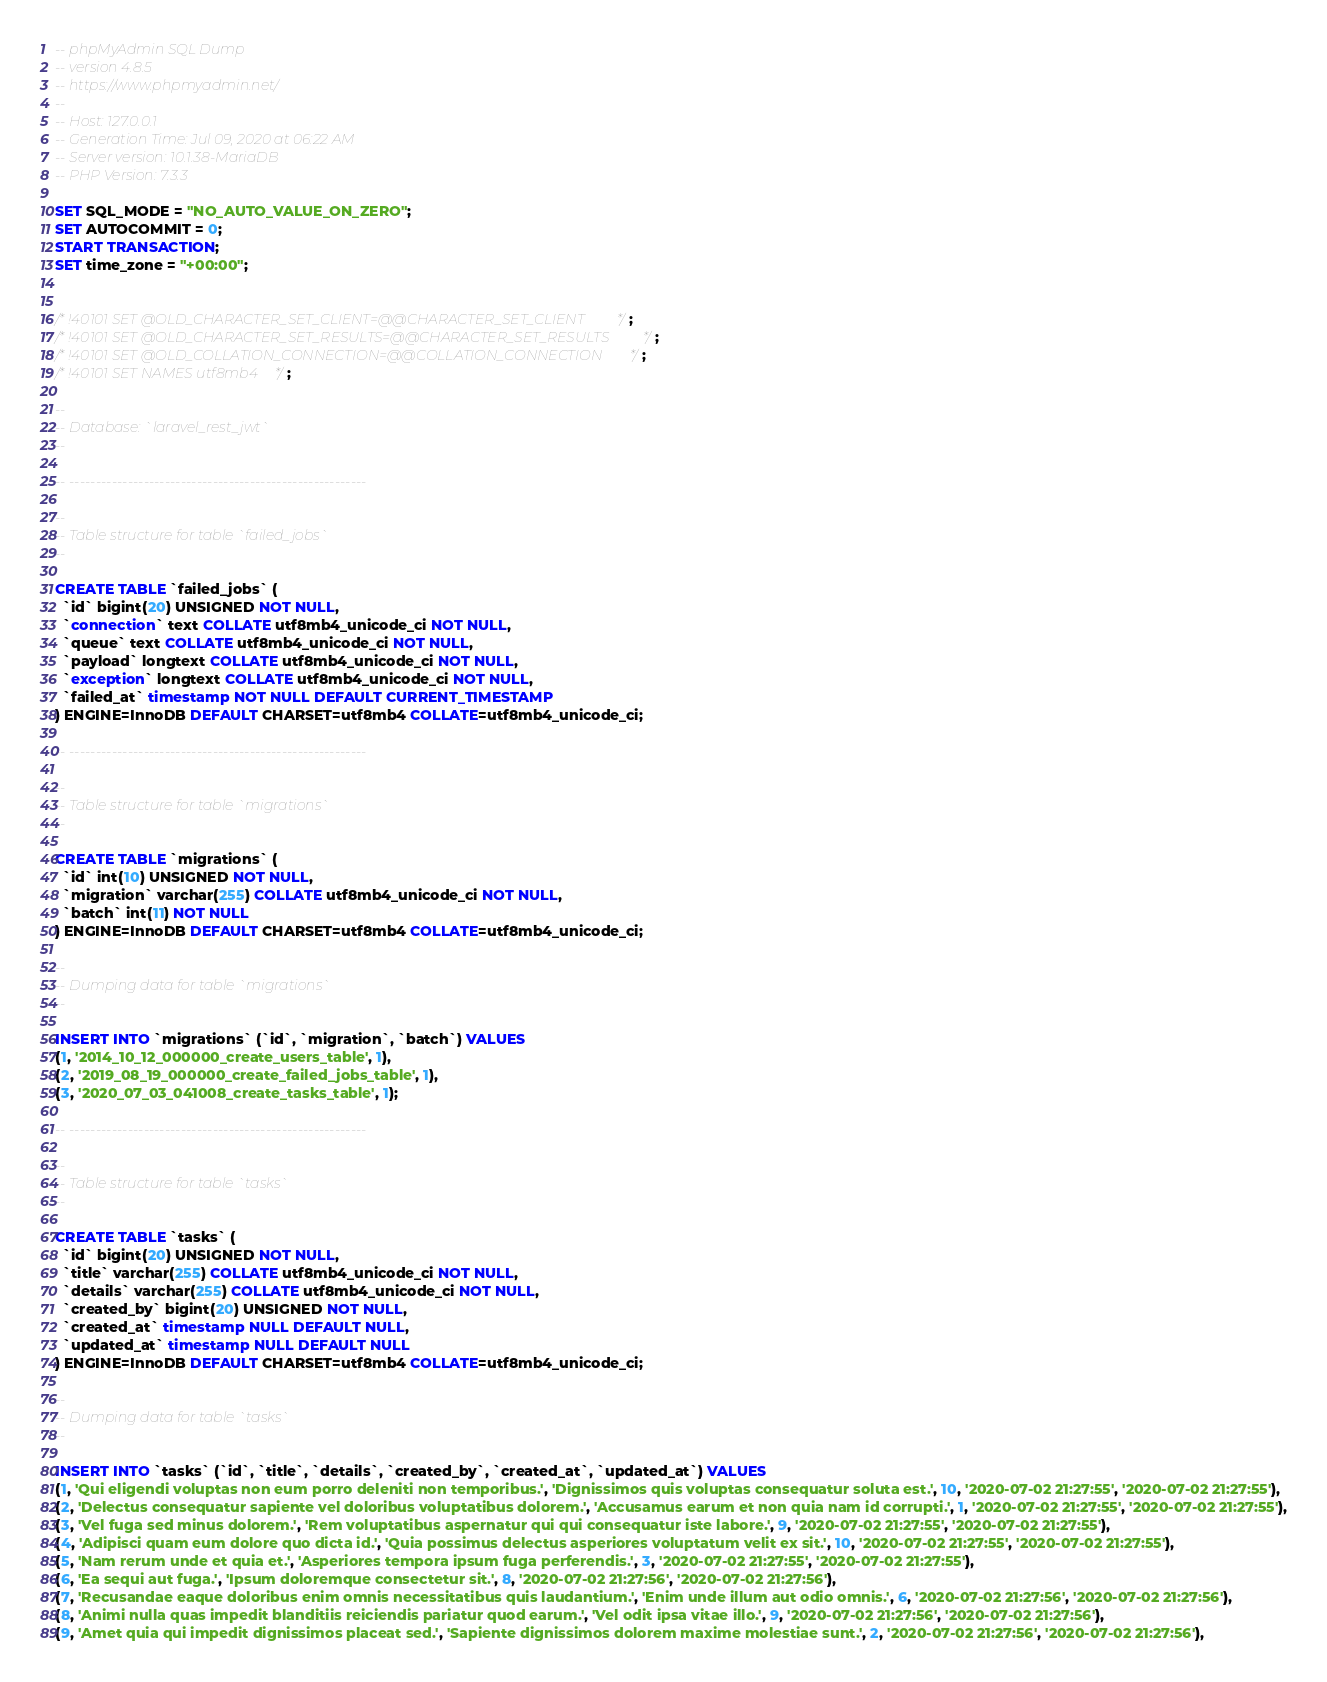<code> <loc_0><loc_0><loc_500><loc_500><_SQL_>-- phpMyAdmin SQL Dump
-- version 4.8.5
-- https://www.phpmyadmin.net/
--
-- Host: 127.0.0.1
-- Generation Time: Jul 09, 2020 at 06:22 AM
-- Server version: 10.1.38-MariaDB
-- PHP Version: 7.3.3

SET SQL_MODE = "NO_AUTO_VALUE_ON_ZERO";
SET AUTOCOMMIT = 0;
START TRANSACTION;
SET time_zone = "+00:00";


/*!40101 SET @OLD_CHARACTER_SET_CLIENT=@@CHARACTER_SET_CLIENT */;
/*!40101 SET @OLD_CHARACTER_SET_RESULTS=@@CHARACTER_SET_RESULTS */;
/*!40101 SET @OLD_COLLATION_CONNECTION=@@COLLATION_CONNECTION */;
/*!40101 SET NAMES utf8mb4 */;

--
-- Database: `laravel_rest_jwt`
--

-- --------------------------------------------------------

--
-- Table structure for table `failed_jobs`
--

CREATE TABLE `failed_jobs` (
  `id` bigint(20) UNSIGNED NOT NULL,
  `connection` text COLLATE utf8mb4_unicode_ci NOT NULL,
  `queue` text COLLATE utf8mb4_unicode_ci NOT NULL,
  `payload` longtext COLLATE utf8mb4_unicode_ci NOT NULL,
  `exception` longtext COLLATE utf8mb4_unicode_ci NOT NULL,
  `failed_at` timestamp NOT NULL DEFAULT CURRENT_TIMESTAMP
) ENGINE=InnoDB DEFAULT CHARSET=utf8mb4 COLLATE=utf8mb4_unicode_ci;

-- --------------------------------------------------------

--
-- Table structure for table `migrations`
--

CREATE TABLE `migrations` (
  `id` int(10) UNSIGNED NOT NULL,
  `migration` varchar(255) COLLATE utf8mb4_unicode_ci NOT NULL,
  `batch` int(11) NOT NULL
) ENGINE=InnoDB DEFAULT CHARSET=utf8mb4 COLLATE=utf8mb4_unicode_ci;

--
-- Dumping data for table `migrations`
--

INSERT INTO `migrations` (`id`, `migration`, `batch`) VALUES
(1, '2014_10_12_000000_create_users_table', 1),
(2, '2019_08_19_000000_create_failed_jobs_table', 1),
(3, '2020_07_03_041008_create_tasks_table', 1);

-- --------------------------------------------------------

--
-- Table structure for table `tasks`
--

CREATE TABLE `tasks` (
  `id` bigint(20) UNSIGNED NOT NULL,
  `title` varchar(255) COLLATE utf8mb4_unicode_ci NOT NULL,
  `details` varchar(255) COLLATE utf8mb4_unicode_ci NOT NULL,
  `created_by` bigint(20) UNSIGNED NOT NULL,
  `created_at` timestamp NULL DEFAULT NULL,
  `updated_at` timestamp NULL DEFAULT NULL
) ENGINE=InnoDB DEFAULT CHARSET=utf8mb4 COLLATE=utf8mb4_unicode_ci;

--
-- Dumping data for table `tasks`
--

INSERT INTO `tasks` (`id`, `title`, `details`, `created_by`, `created_at`, `updated_at`) VALUES
(1, 'Qui eligendi voluptas non eum porro deleniti non temporibus.', 'Dignissimos quis voluptas consequatur soluta est.', 10, '2020-07-02 21:27:55', '2020-07-02 21:27:55'),
(2, 'Delectus consequatur sapiente vel doloribus voluptatibus dolorem.', 'Accusamus earum et non quia nam id corrupti.', 1, '2020-07-02 21:27:55', '2020-07-02 21:27:55'),
(3, 'Vel fuga sed minus dolorem.', 'Rem voluptatibus aspernatur qui qui consequatur iste labore.', 9, '2020-07-02 21:27:55', '2020-07-02 21:27:55'),
(4, 'Adipisci quam eum dolore quo dicta id.', 'Quia possimus delectus asperiores voluptatum velit ex sit.', 10, '2020-07-02 21:27:55', '2020-07-02 21:27:55'),
(5, 'Nam rerum unde et quia et.', 'Asperiores tempora ipsum fuga perferendis.', 3, '2020-07-02 21:27:55', '2020-07-02 21:27:55'),
(6, 'Ea sequi aut fuga.', 'Ipsum doloremque consectetur sit.', 8, '2020-07-02 21:27:56', '2020-07-02 21:27:56'),
(7, 'Recusandae eaque doloribus enim omnis necessitatibus quis laudantium.', 'Enim unde illum aut odio omnis.', 6, '2020-07-02 21:27:56', '2020-07-02 21:27:56'),
(8, 'Animi nulla quas impedit blanditiis reiciendis pariatur quod earum.', 'Vel odit ipsa vitae illo.', 9, '2020-07-02 21:27:56', '2020-07-02 21:27:56'),
(9, 'Amet quia qui impedit dignissimos placeat sed.', 'Sapiente dignissimos dolorem maxime molestiae sunt.', 2, '2020-07-02 21:27:56', '2020-07-02 21:27:56'),</code> 